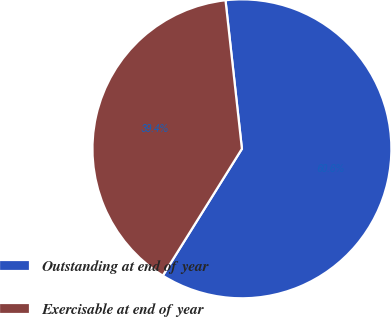<chart> <loc_0><loc_0><loc_500><loc_500><pie_chart><fcel>Outstanding at end of year<fcel>Exercisable at end of year<nl><fcel>60.63%<fcel>39.37%<nl></chart> 